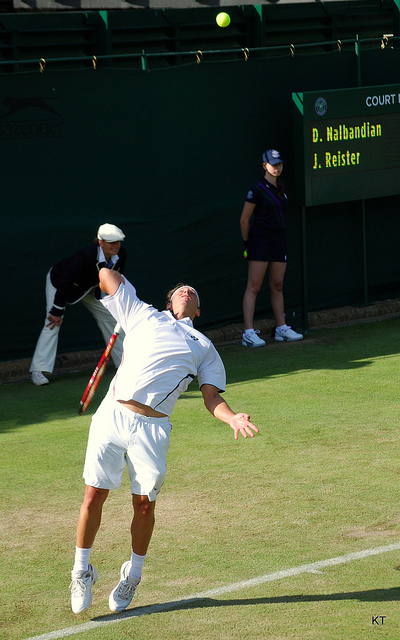<image>What technique is being demonstrated? It is unknown what technique is being demonstrated. It can be seen backhand, tennis, forehand, serve, smashing or hitting. What technique is being demonstrated? I'm not sure what technique is being demonstrated. It could be 'backhand', 'tennis', 'forehand', 'serve', 'smashing', or 'hitting'. 